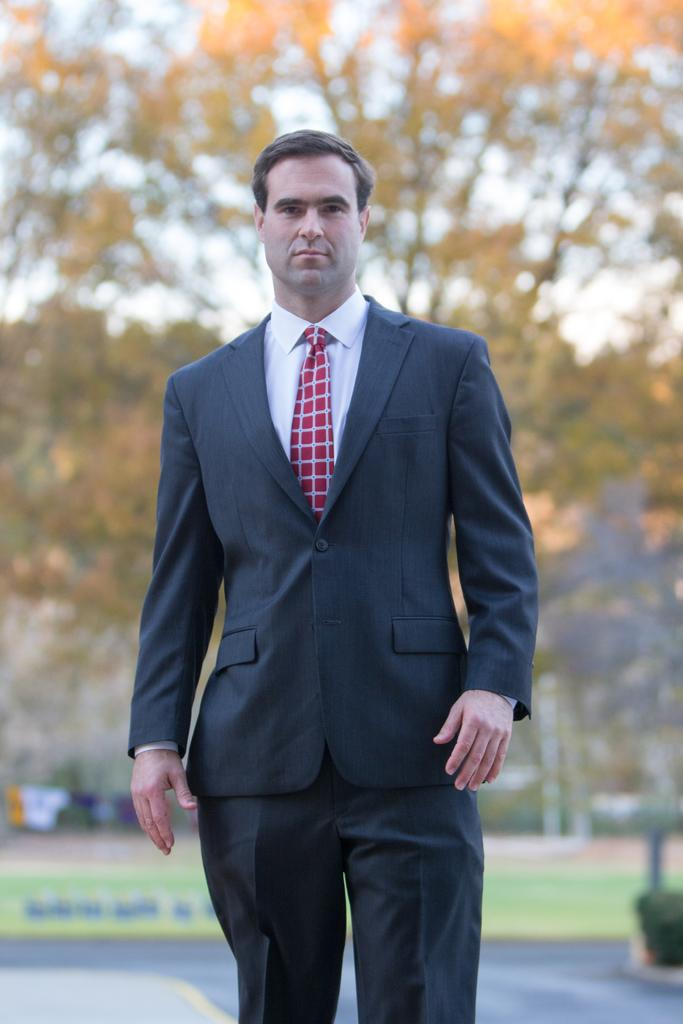What is the main subject of the image? There is a man standing in the image. What can be seen in the background of the image? There are trees and the sky visible in the background of the image. What type of humor can be seen in the man's shoe in the image? There is no shoe visible in the image, and therefore no humor can be attributed to it. 